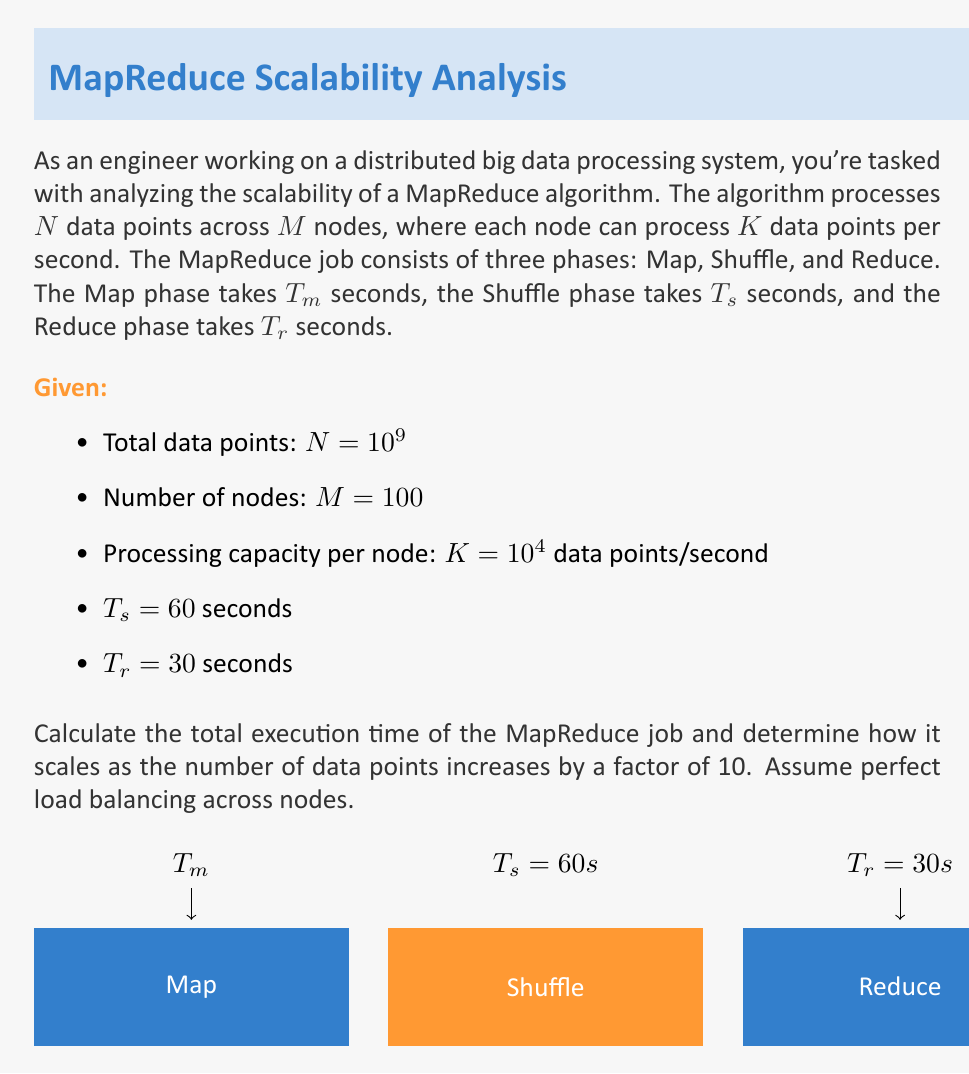What is the answer to this math problem? Let's approach this problem step-by-step:

1) First, we need to calculate $T_m$, the time for the Map phase:
   - Total data points to process: $N = 10^9$
   - Total processing capacity of the system: $M \times K = 100 \times 10^4 = 10^6$ data points/second
   - $T_m = \frac{N}{M \times K} = \frac{10^9}{10^6} = 1000$ seconds

2) Now we can calculate the total execution time $T$:
   $T = T_m + T_s + T_r = 1000 + 60 + 30 = 1090$ seconds

3) To determine how it scales when $N$ increases by a factor of 10:
   - New $N = 10 \times 10^9 = 10^{10}$
   - New $T_m = \frac{10^{10}}{10^6} = 10000$ seconds
   - New total time $T_{new} = 10000 + 60 + 30 = 10090$ seconds

4) The scaling factor is:
   $\frac{T_{new}}{T} = \frac{10090}{1090} \approx 9.26$

5) This shows that the execution time increases almost linearly with the increase in data points. It's slightly less than 10 due to the constant times of Shuffle and Reduce phases.

6) The scalability can be considered good because:
   - The dominant factor (Map phase) scales linearly with the data size
   - The Shuffle and Reduce phases remain constant, becoming relatively less significant as data size grows
Answer: Total execution time: 1090 seconds. Scales approximately linearly (by a factor of 9.26) when data increases 10-fold. 